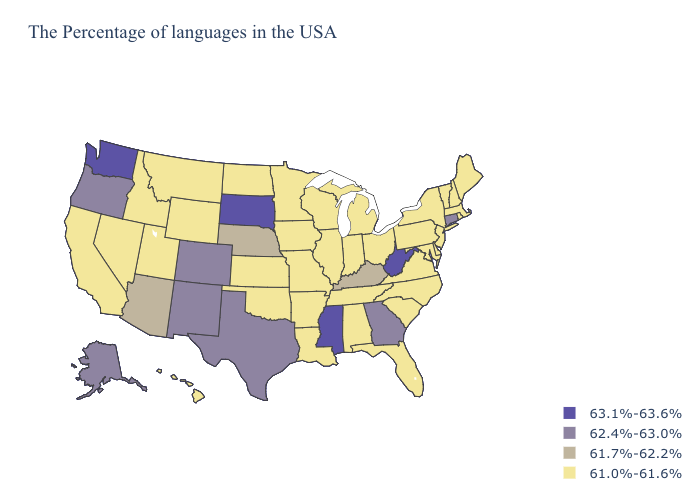Name the states that have a value in the range 62.4%-63.0%?
Short answer required. Connecticut, Georgia, Texas, Colorado, New Mexico, Oregon, Alaska. Name the states that have a value in the range 63.1%-63.6%?
Concise answer only. West Virginia, Mississippi, South Dakota, Washington. Does the map have missing data?
Keep it brief. No. What is the highest value in the MidWest ?
Be succinct. 63.1%-63.6%. What is the value of Washington?
Give a very brief answer. 63.1%-63.6%. What is the value of Alabama?
Write a very short answer. 61.0%-61.6%. Name the states that have a value in the range 61.7%-62.2%?
Short answer required. Kentucky, Nebraska, Arizona. Name the states that have a value in the range 61.7%-62.2%?
Give a very brief answer. Kentucky, Nebraska, Arizona. Does South Dakota have the highest value in the USA?
Keep it brief. Yes. Does the first symbol in the legend represent the smallest category?
Short answer required. No. Name the states that have a value in the range 62.4%-63.0%?
Keep it brief. Connecticut, Georgia, Texas, Colorado, New Mexico, Oregon, Alaska. How many symbols are there in the legend?
Answer briefly. 4. Name the states that have a value in the range 63.1%-63.6%?
Be succinct. West Virginia, Mississippi, South Dakota, Washington. What is the lowest value in states that border Delaware?
Short answer required. 61.0%-61.6%. What is the lowest value in the USA?
Concise answer only. 61.0%-61.6%. 